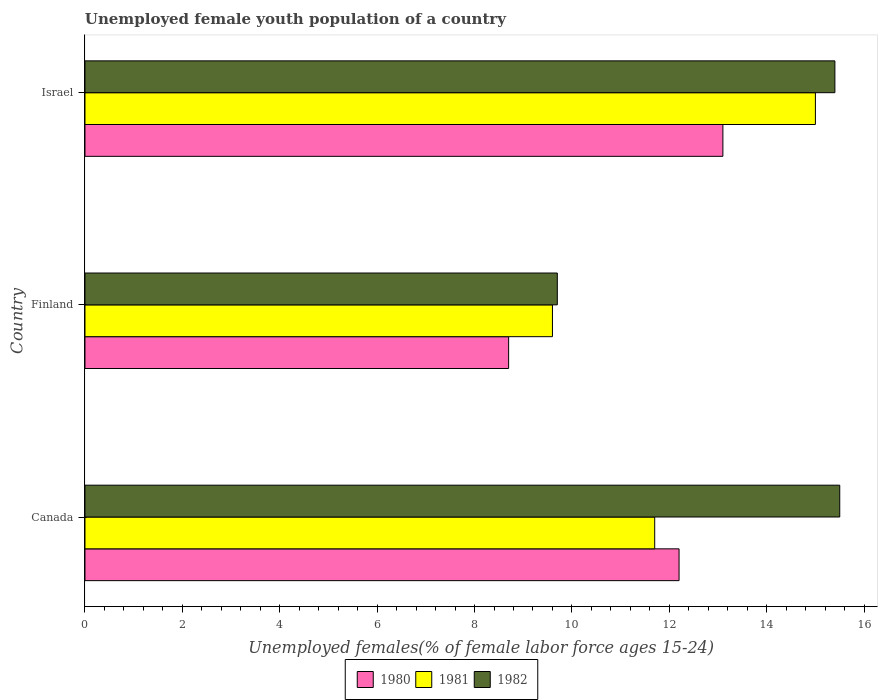How many groups of bars are there?
Provide a succinct answer. 3. Are the number of bars per tick equal to the number of legend labels?
Your answer should be compact. Yes. How many bars are there on the 3rd tick from the bottom?
Provide a succinct answer. 3. What is the label of the 1st group of bars from the top?
Your answer should be compact. Israel. In how many cases, is the number of bars for a given country not equal to the number of legend labels?
Your answer should be very brief. 0. Across all countries, what is the maximum percentage of unemployed female youth population in 1980?
Ensure brevity in your answer.  13.1. Across all countries, what is the minimum percentage of unemployed female youth population in 1981?
Give a very brief answer. 9.6. In which country was the percentage of unemployed female youth population in 1982 maximum?
Give a very brief answer. Canada. In which country was the percentage of unemployed female youth population in 1982 minimum?
Your answer should be compact. Finland. What is the total percentage of unemployed female youth population in 1980 in the graph?
Your answer should be very brief. 34. What is the difference between the percentage of unemployed female youth population in 1981 in Finland and that in Israel?
Provide a succinct answer. -5.4. What is the difference between the percentage of unemployed female youth population in 1982 in Canada and the percentage of unemployed female youth population in 1981 in Finland?
Offer a very short reply. 5.9. What is the average percentage of unemployed female youth population in 1981 per country?
Make the answer very short. 12.1. What is the difference between the percentage of unemployed female youth population in 1980 and percentage of unemployed female youth population in 1982 in Canada?
Your response must be concise. -3.3. In how many countries, is the percentage of unemployed female youth population in 1982 greater than 4.4 %?
Ensure brevity in your answer.  3. What is the ratio of the percentage of unemployed female youth population in 1980 in Canada to that in Israel?
Your response must be concise. 0.93. What is the difference between the highest and the second highest percentage of unemployed female youth population in 1982?
Give a very brief answer. 0.1. What is the difference between the highest and the lowest percentage of unemployed female youth population in 1981?
Give a very brief answer. 5.4. In how many countries, is the percentage of unemployed female youth population in 1980 greater than the average percentage of unemployed female youth population in 1980 taken over all countries?
Your answer should be very brief. 2. Is the sum of the percentage of unemployed female youth population in 1980 in Canada and Finland greater than the maximum percentage of unemployed female youth population in 1981 across all countries?
Your answer should be very brief. Yes. Are all the bars in the graph horizontal?
Make the answer very short. Yes. What is the difference between two consecutive major ticks on the X-axis?
Make the answer very short. 2. Are the values on the major ticks of X-axis written in scientific E-notation?
Offer a terse response. No. Does the graph contain grids?
Your answer should be very brief. No. How many legend labels are there?
Make the answer very short. 3. What is the title of the graph?
Provide a short and direct response. Unemployed female youth population of a country. Does "1976" appear as one of the legend labels in the graph?
Offer a very short reply. No. What is the label or title of the X-axis?
Provide a succinct answer. Unemployed females(% of female labor force ages 15-24). What is the label or title of the Y-axis?
Provide a short and direct response. Country. What is the Unemployed females(% of female labor force ages 15-24) of 1980 in Canada?
Provide a succinct answer. 12.2. What is the Unemployed females(% of female labor force ages 15-24) in 1981 in Canada?
Offer a very short reply. 11.7. What is the Unemployed females(% of female labor force ages 15-24) of 1982 in Canada?
Keep it short and to the point. 15.5. What is the Unemployed females(% of female labor force ages 15-24) of 1980 in Finland?
Give a very brief answer. 8.7. What is the Unemployed females(% of female labor force ages 15-24) in 1981 in Finland?
Provide a short and direct response. 9.6. What is the Unemployed females(% of female labor force ages 15-24) in 1982 in Finland?
Offer a terse response. 9.7. What is the Unemployed females(% of female labor force ages 15-24) in 1980 in Israel?
Offer a terse response. 13.1. What is the Unemployed females(% of female labor force ages 15-24) of 1981 in Israel?
Your answer should be very brief. 15. What is the Unemployed females(% of female labor force ages 15-24) in 1982 in Israel?
Your answer should be very brief. 15.4. Across all countries, what is the maximum Unemployed females(% of female labor force ages 15-24) in 1980?
Ensure brevity in your answer.  13.1. Across all countries, what is the minimum Unemployed females(% of female labor force ages 15-24) of 1980?
Provide a succinct answer. 8.7. Across all countries, what is the minimum Unemployed females(% of female labor force ages 15-24) in 1981?
Keep it short and to the point. 9.6. Across all countries, what is the minimum Unemployed females(% of female labor force ages 15-24) of 1982?
Your answer should be very brief. 9.7. What is the total Unemployed females(% of female labor force ages 15-24) of 1981 in the graph?
Your response must be concise. 36.3. What is the total Unemployed females(% of female labor force ages 15-24) in 1982 in the graph?
Make the answer very short. 40.6. What is the difference between the Unemployed females(% of female labor force ages 15-24) of 1980 in Canada and that in Finland?
Ensure brevity in your answer.  3.5. What is the difference between the Unemployed females(% of female labor force ages 15-24) in 1981 in Canada and that in Finland?
Provide a short and direct response. 2.1. What is the difference between the Unemployed females(% of female labor force ages 15-24) of 1982 in Canada and that in Finland?
Make the answer very short. 5.8. What is the difference between the Unemployed females(% of female labor force ages 15-24) of 1982 in Finland and that in Israel?
Your answer should be very brief. -5.7. What is the difference between the Unemployed females(% of female labor force ages 15-24) of 1980 in Canada and the Unemployed females(% of female labor force ages 15-24) of 1981 in Finland?
Keep it short and to the point. 2.6. What is the difference between the Unemployed females(% of female labor force ages 15-24) in 1980 in Canada and the Unemployed females(% of female labor force ages 15-24) in 1981 in Israel?
Your answer should be very brief. -2.8. What is the difference between the Unemployed females(% of female labor force ages 15-24) of 1980 in Canada and the Unemployed females(% of female labor force ages 15-24) of 1982 in Israel?
Offer a terse response. -3.2. What is the difference between the Unemployed females(% of female labor force ages 15-24) of 1981 in Canada and the Unemployed females(% of female labor force ages 15-24) of 1982 in Israel?
Offer a terse response. -3.7. What is the difference between the Unemployed females(% of female labor force ages 15-24) in 1980 in Finland and the Unemployed females(% of female labor force ages 15-24) in 1982 in Israel?
Keep it short and to the point. -6.7. What is the average Unemployed females(% of female labor force ages 15-24) of 1980 per country?
Your response must be concise. 11.33. What is the average Unemployed females(% of female labor force ages 15-24) of 1981 per country?
Make the answer very short. 12.1. What is the average Unemployed females(% of female labor force ages 15-24) in 1982 per country?
Offer a very short reply. 13.53. What is the difference between the Unemployed females(% of female labor force ages 15-24) in 1980 and Unemployed females(% of female labor force ages 15-24) in 1982 in Israel?
Keep it short and to the point. -2.3. What is the ratio of the Unemployed females(% of female labor force ages 15-24) in 1980 in Canada to that in Finland?
Offer a very short reply. 1.4. What is the ratio of the Unemployed females(% of female labor force ages 15-24) of 1981 in Canada to that in Finland?
Offer a terse response. 1.22. What is the ratio of the Unemployed females(% of female labor force ages 15-24) of 1982 in Canada to that in Finland?
Provide a succinct answer. 1.6. What is the ratio of the Unemployed females(% of female labor force ages 15-24) of 1980 in Canada to that in Israel?
Give a very brief answer. 0.93. What is the ratio of the Unemployed females(% of female labor force ages 15-24) of 1981 in Canada to that in Israel?
Provide a short and direct response. 0.78. What is the ratio of the Unemployed females(% of female labor force ages 15-24) of 1980 in Finland to that in Israel?
Your answer should be compact. 0.66. What is the ratio of the Unemployed females(% of female labor force ages 15-24) of 1981 in Finland to that in Israel?
Offer a very short reply. 0.64. What is the ratio of the Unemployed females(% of female labor force ages 15-24) of 1982 in Finland to that in Israel?
Offer a very short reply. 0.63. What is the difference between the highest and the second highest Unemployed females(% of female labor force ages 15-24) of 1980?
Keep it short and to the point. 0.9. What is the difference between the highest and the second highest Unemployed females(% of female labor force ages 15-24) of 1981?
Your response must be concise. 3.3. What is the difference between the highest and the second highest Unemployed females(% of female labor force ages 15-24) in 1982?
Your answer should be compact. 0.1. What is the difference between the highest and the lowest Unemployed females(% of female labor force ages 15-24) of 1982?
Make the answer very short. 5.8. 